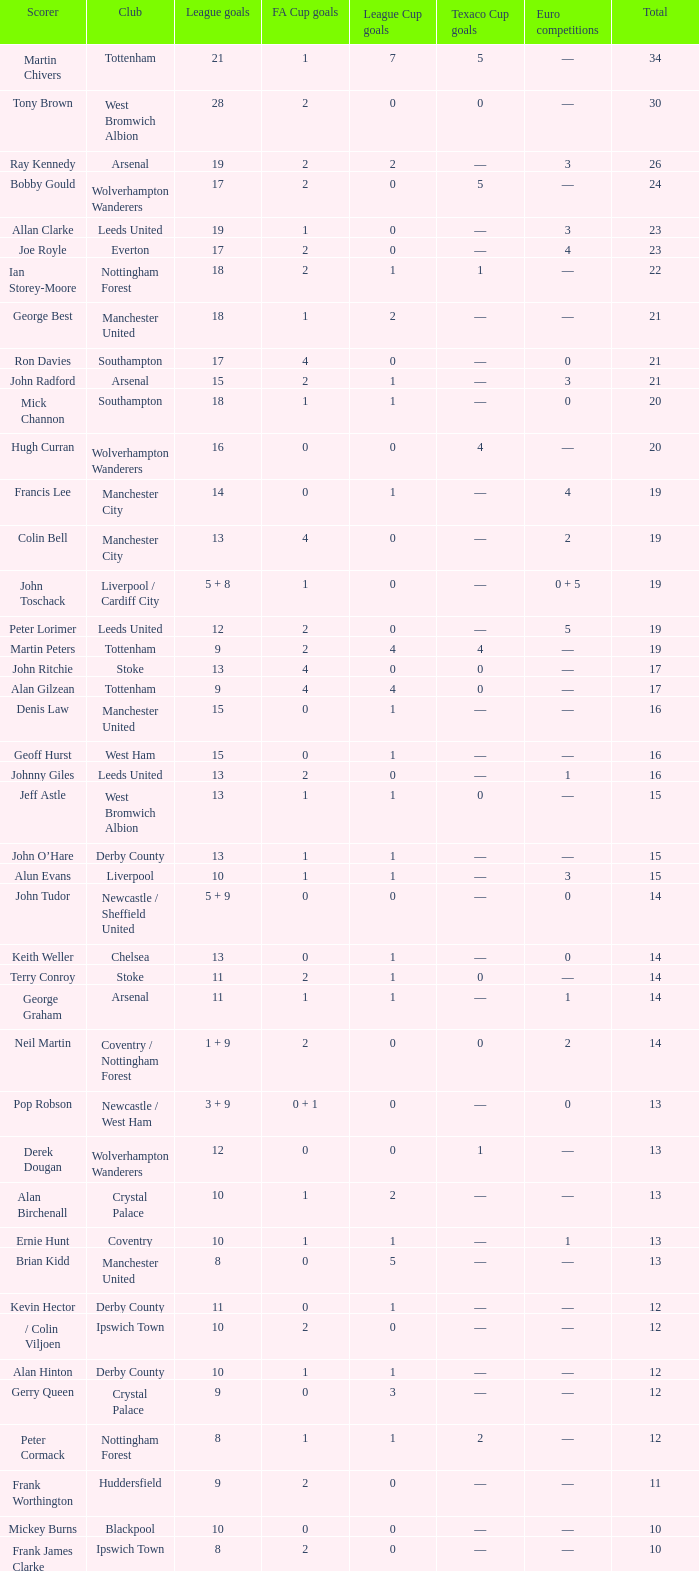What is the smallest number of league cup goals scored by denis law? 1.0. 